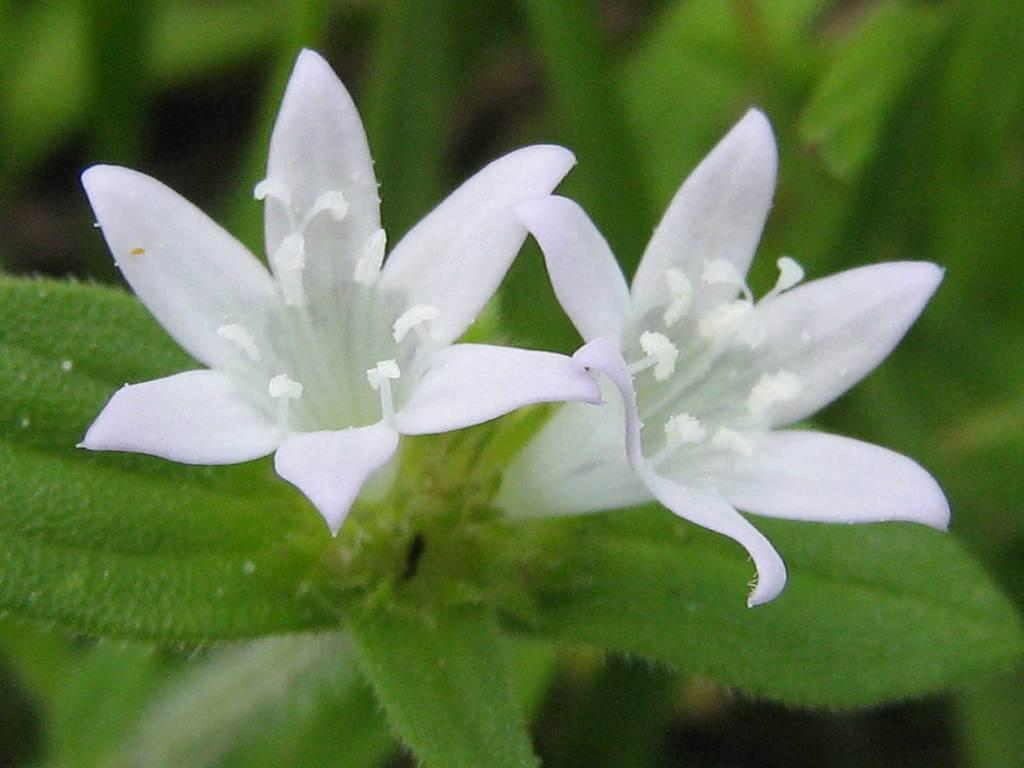What type of flowers can be seen in the image? There are white color flowers in the image. What color are the leaves associated with the flowers? There are green leaves in the image. What type of company is represented by the sofa in the image? There is no sofa present in the image, so it is not possible to determine what type of company might be represented. 